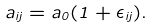<formula> <loc_0><loc_0><loc_500><loc_500>a _ { i j } = a _ { 0 } ( 1 + \epsilon _ { i j } ) .</formula> 